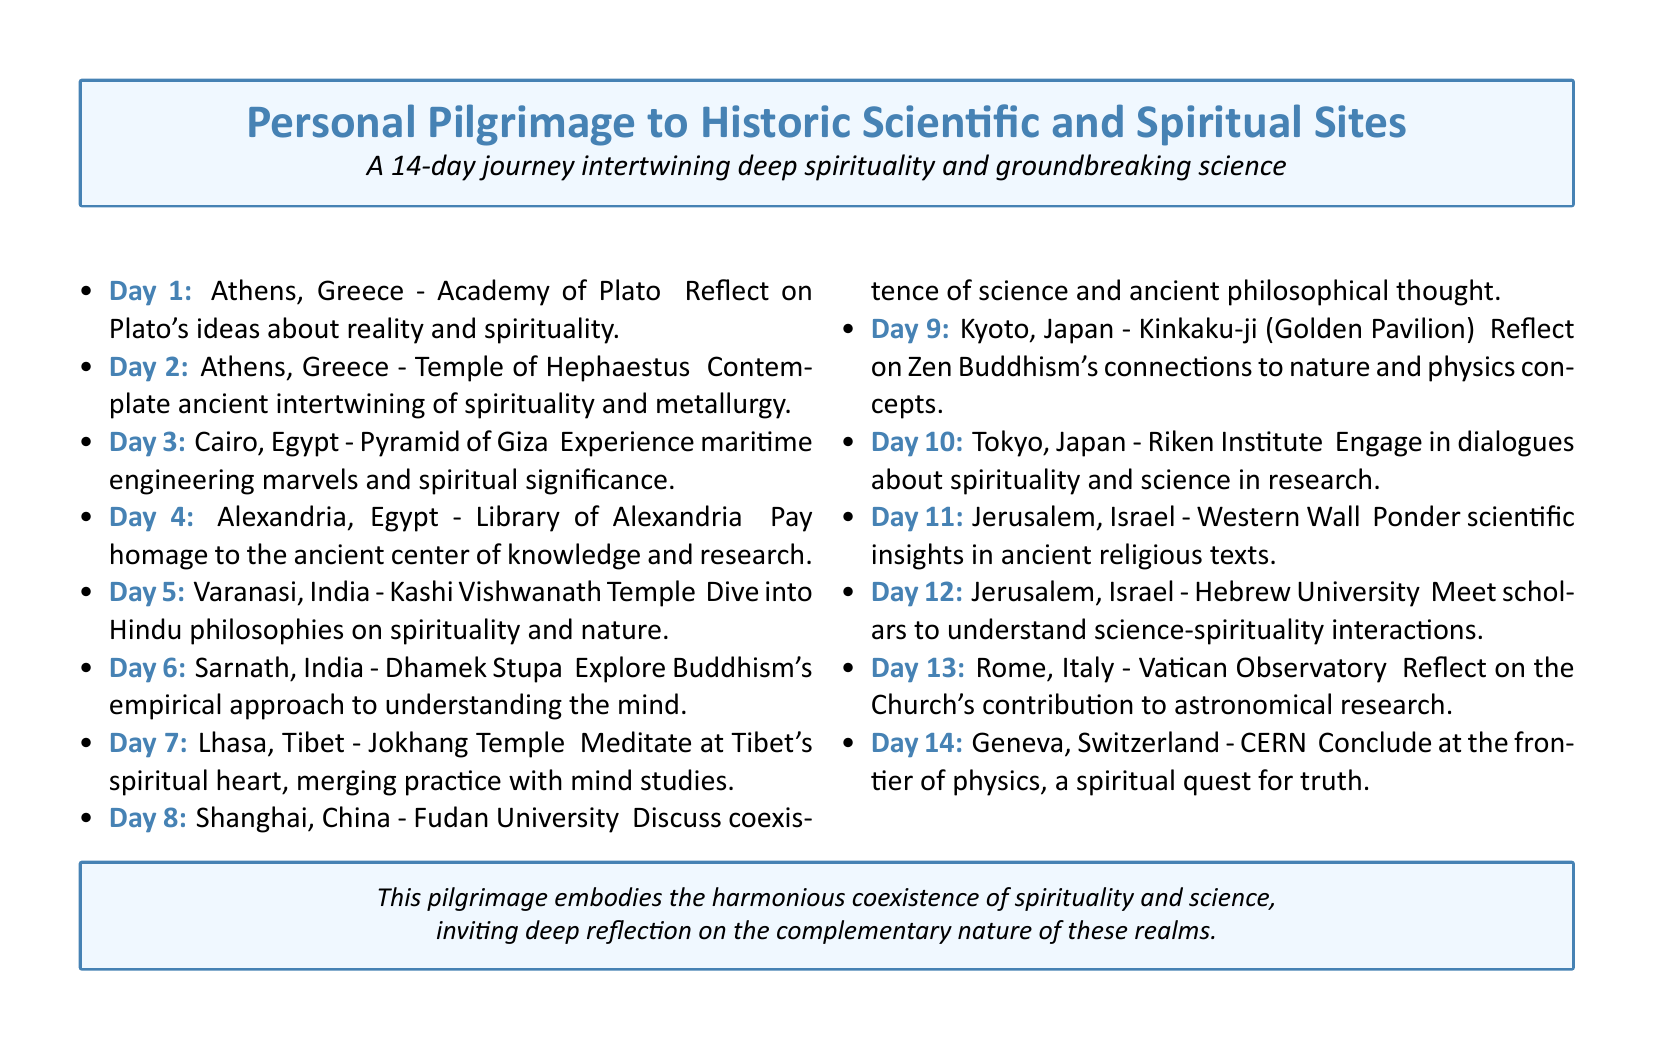What is the starting location of the pilgrimage? The document mentions Athens, Greece as the first destination of the pilgrimage.
Answer: Athens, Greece How many days is the pilgrimage scheduled for? The document outlines a journey that lasts for 14 days.
Answer: 14 Which temple is visited on Day 5? The document specifies that Kashi Vishwanath Temple in Varanasi, India is visited on Day 5.
Answer: Kashi Vishwanath Temple What ancient site's significance is highlighted in relation to knowledge? The document refers to the Library of Alexandria as an ancient center of knowledge and research.
Answer: Library of Alexandria What is discussed at Fudan University? The document states there will be discussions about the coexistence of science and ancient philosophical thought at Fudan University.
Answer: Coexistence of science and ancient philosophical thought How many sites are in Jerusalem on this pilgrimage? The document lists two specific sites in Jerusalem, the Western Wall and Hebrew University.
Answer: Two What is the purpose of concluding the pilgrimage at CERN? The document indicates that concluding at CERN represents a spiritual quest for truth in the frontier of physics.
Answer: Spiritual quest for truth Which institute is associated with dialogues about spirituality and science? The document notes that the Riken Institute in Tokyo, Japan is associated with these dialogues.
Answer: Riken Institute What philosophical approach is explored on Day 6 in Sarnath? The document mentions exploring Buddhism's empirical approach to understanding the mind.
Answer: Empirical approach to understanding the mind 